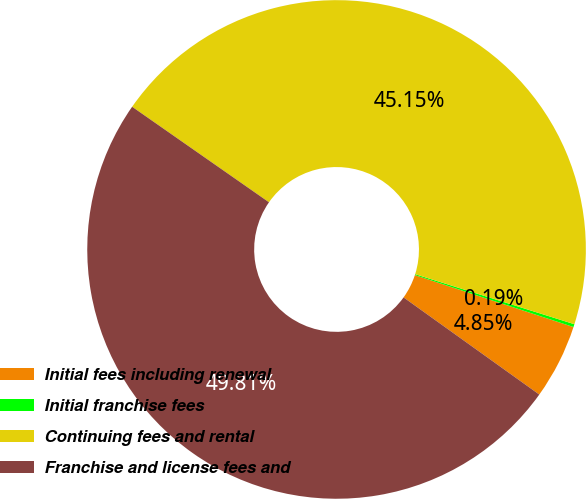Convert chart to OTSL. <chart><loc_0><loc_0><loc_500><loc_500><pie_chart><fcel>Initial fees including renewal<fcel>Initial franchise fees<fcel>Continuing fees and rental<fcel>Franchise and license fees and<nl><fcel>4.85%<fcel>0.19%<fcel>45.15%<fcel>49.81%<nl></chart> 